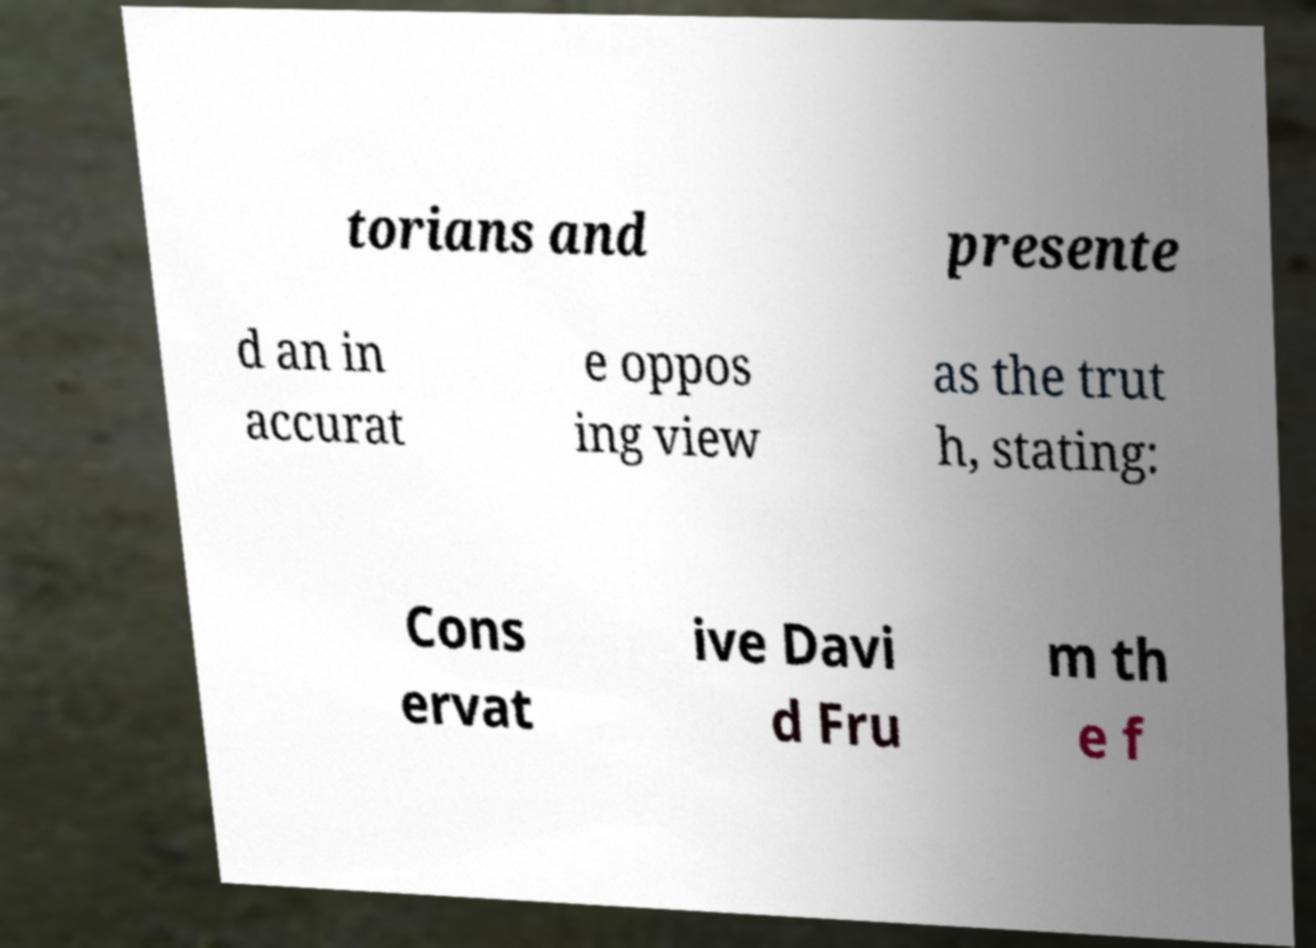Can you accurately transcribe the text from the provided image for me? torians and presente d an in accurat e oppos ing view as the trut h, stating: Cons ervat ive Davi d Fru m th e f 